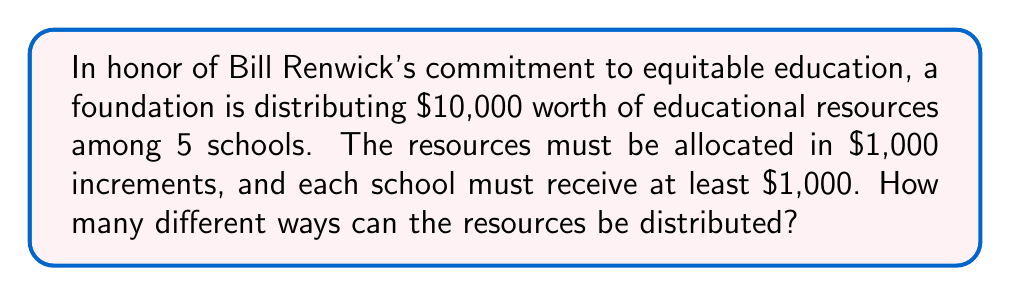What is the answer to this math problem? Let's approach this step-by-step:

1) First, we need to recognize that this is a stars and bars problem. We're distributing 10 indistinguishable units (each representing $1,000) among 5 distinguishable containers (schools).

2) However, there's a constraint: each school must receive at least $1,000. To account for this, we can first give each school $1,000, and then distribute the remaining $5,000.

3) So now we're essentially distributing 5 units ($5,000) among 5 schools, with no restrictions.

4) The formula for stars and bars is:

   $$\binom{n+k-1}{k-1}$$

   Where n is the number of indistinguishable objects and k is the number of distinguishable containers.

5) In our case, n = 5 (remaining $5,000) and k = 5 (schools).

6) Plugging into the formula:

   $$\binom{5+5-1}{5-1} = \binom{9}{4}$$

7) We can calculate this:

   $$\binom{9}{4} = \frac{9!}{4!(9-4)!} = \frac{9!}{4!5!} = 126$$

Therefore, there are 126 different ways to distribute the resources.
Answer: 126 